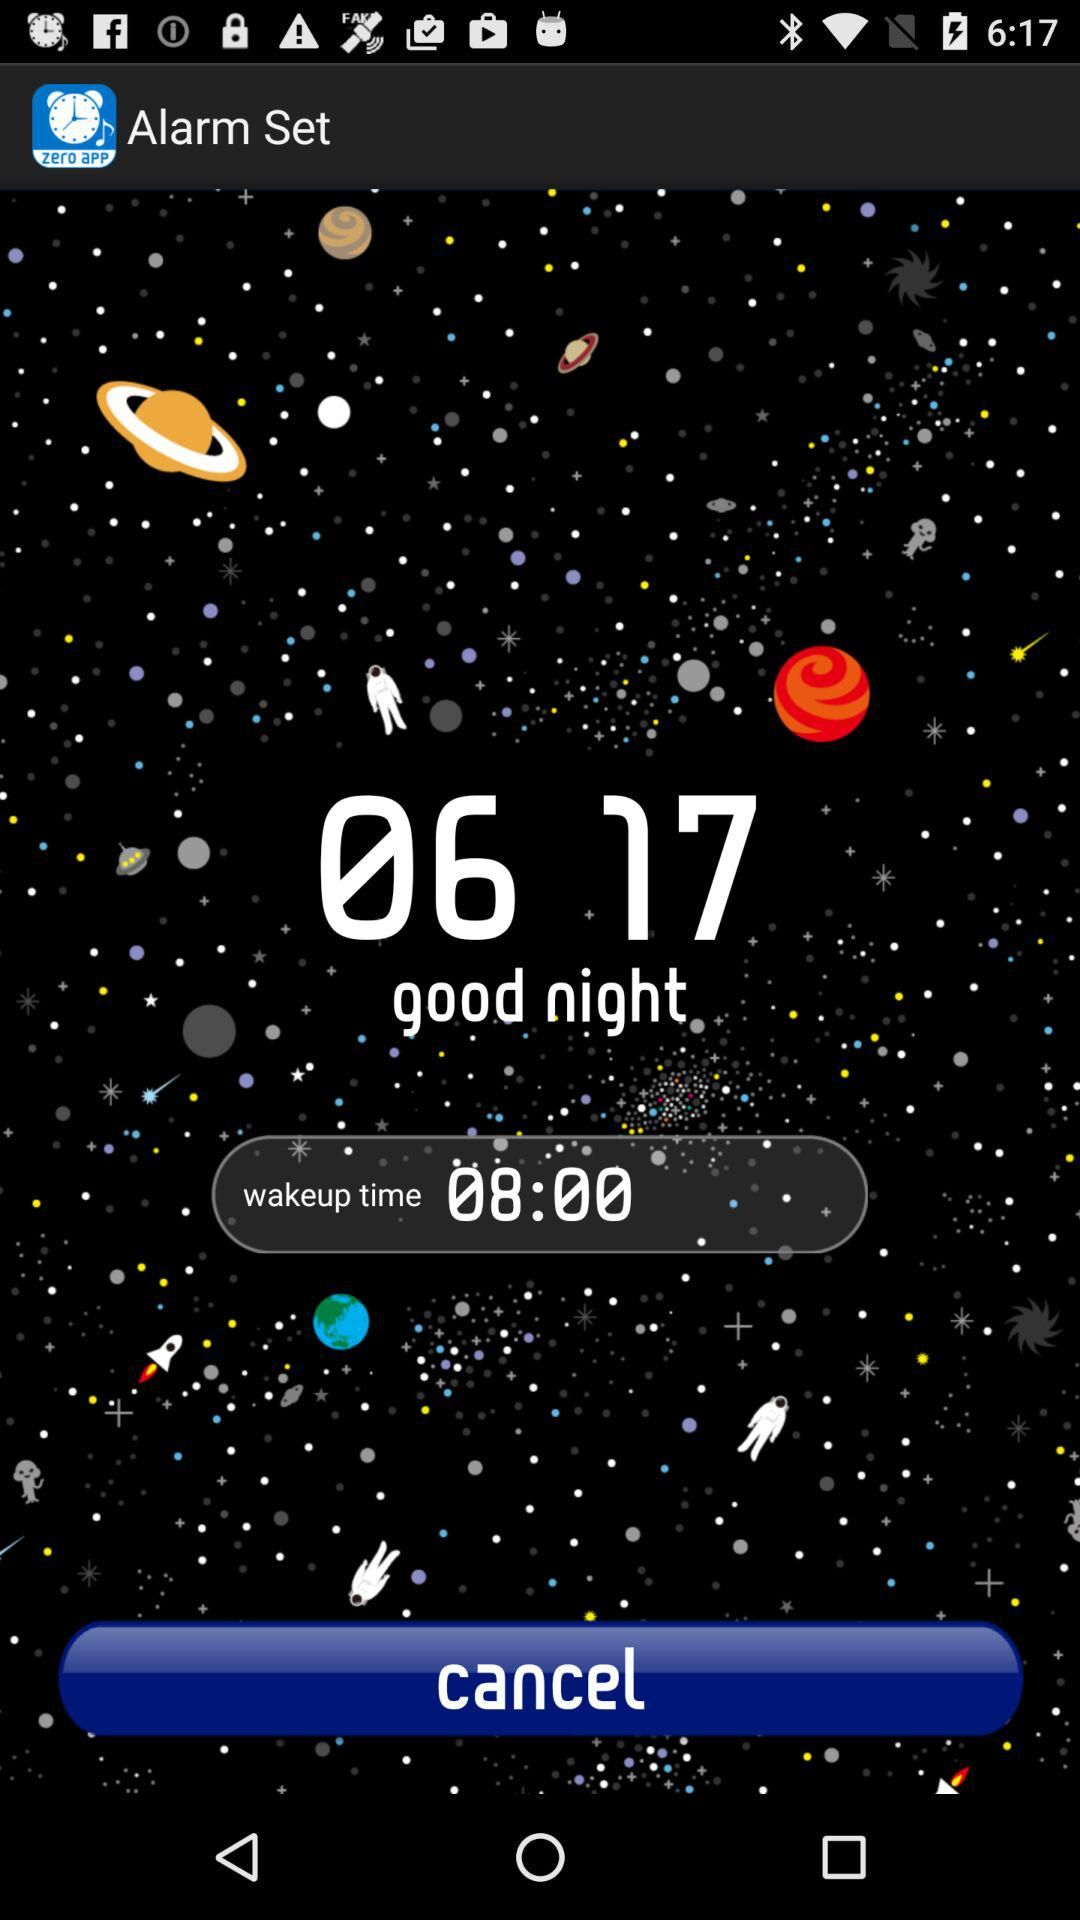What is the application name? The application name is "Alarm Set". 